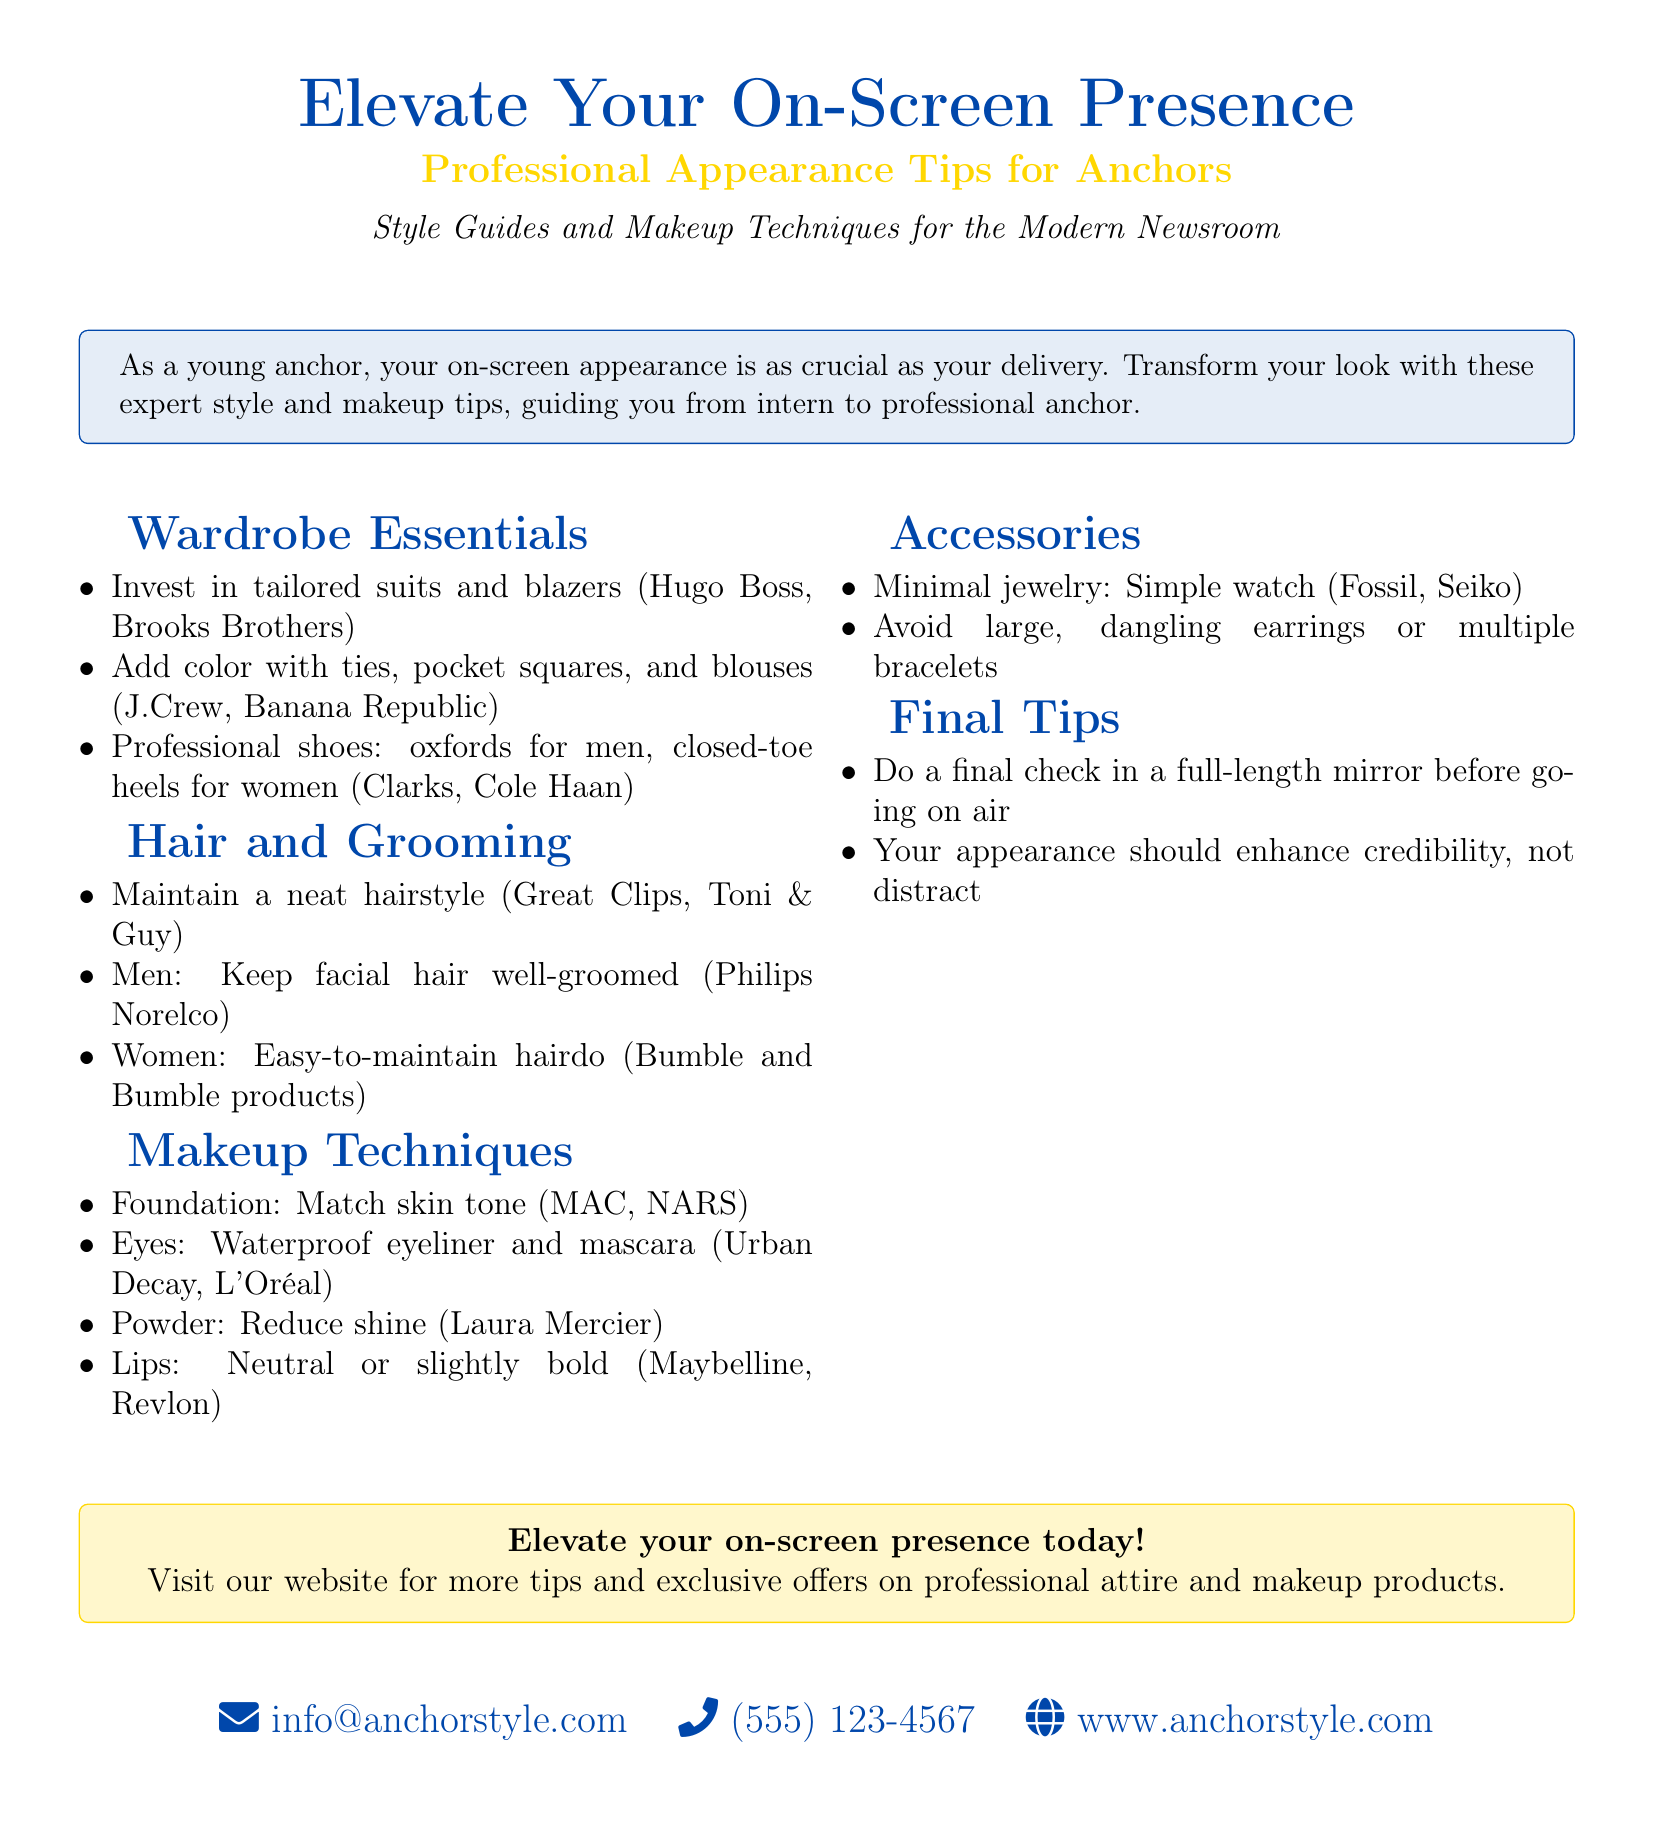What are recommended brands for tailored suits? The document lists Hugo Boss and Brooks Brothers as recommended brands for tailored suits in the wardrobe essentials section.
Answer: Hugo Boss, Brooks Brothers What should men's shoes be? The document specifies that men's professional shoes should be oxfords.
Answer: Oxfords What is a key benefit of using waterproof eyeliner? The document mentions using waterproof eyeliner for the eyes as part of makeup techniques, implying it helps to prevent smudging.
Answer: Prevent smudging What is the advised makeup for lips? The document recommends using neutral or slightly bold colors for lips.
Answer: Neutral or slightly bold How can one enhance their on-screen presence? The document suggests that one's appearance should enhance credibility.
Answer: Enhance credibility What type of hair grooming is mentioned for men? The document advises men to keep their facial hair well-groomed.
Answer: Well-groomed What is recommended for final checks before going on air? The document advises doing a final check in a full-length mirror before going on air.
Answer: Full-length mirror What type of earrings should be avoided? The document states that large, dangling earrings should be avoided as part of accessories.
Answer: Large, dangling earrings What is the contact email provided in the document? The document includes the email address info@anchorstyle.com for contacting.
Answer: info@anchorstyle.com 